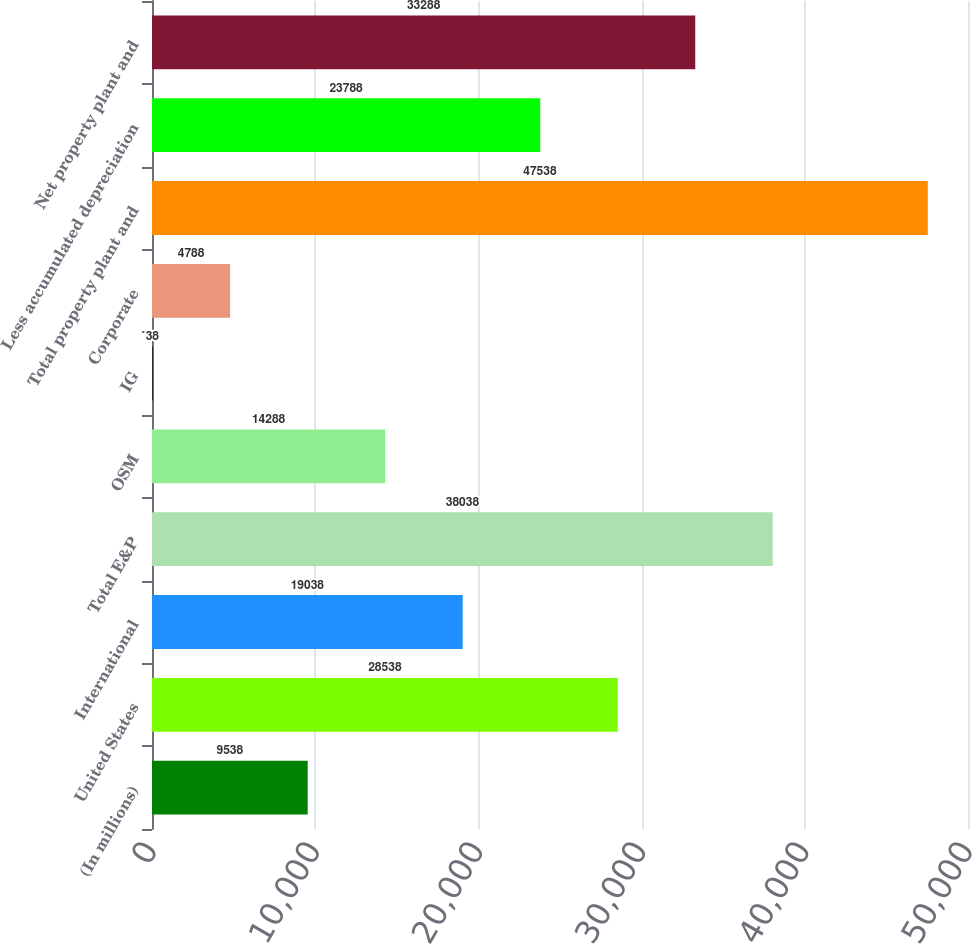Convert chart. <chart><loc_0><loc_0><loc_500><loc_500><bar_chart><fcel>(In millions)<fcel>United States<fcel>International<fcel>Total E&P<fcel>OSM<fcel>IG<fcel>Corporate<fcel>Total property plant and<fcel>Less accumulated depreciation<fcel>Net property plant and<nl><fcel>9538<fcel>28538<fcel>19038<fcel>38038<fcel>14288<fcel>38<fcel>4788<fcel>47538<fcel>23788<fcel>33288<nl></chart> 